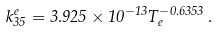Convert formula to latex. <formula><loc_0><loc_0><loc_500><loc_500>k _ { 3 5 } ^ { e } = 3 . 9 2 5 \times 1 0 ^ { - 1 3 } T _ { e } ^ { - 0 . 6 3 5 3 } \, .</formula> 